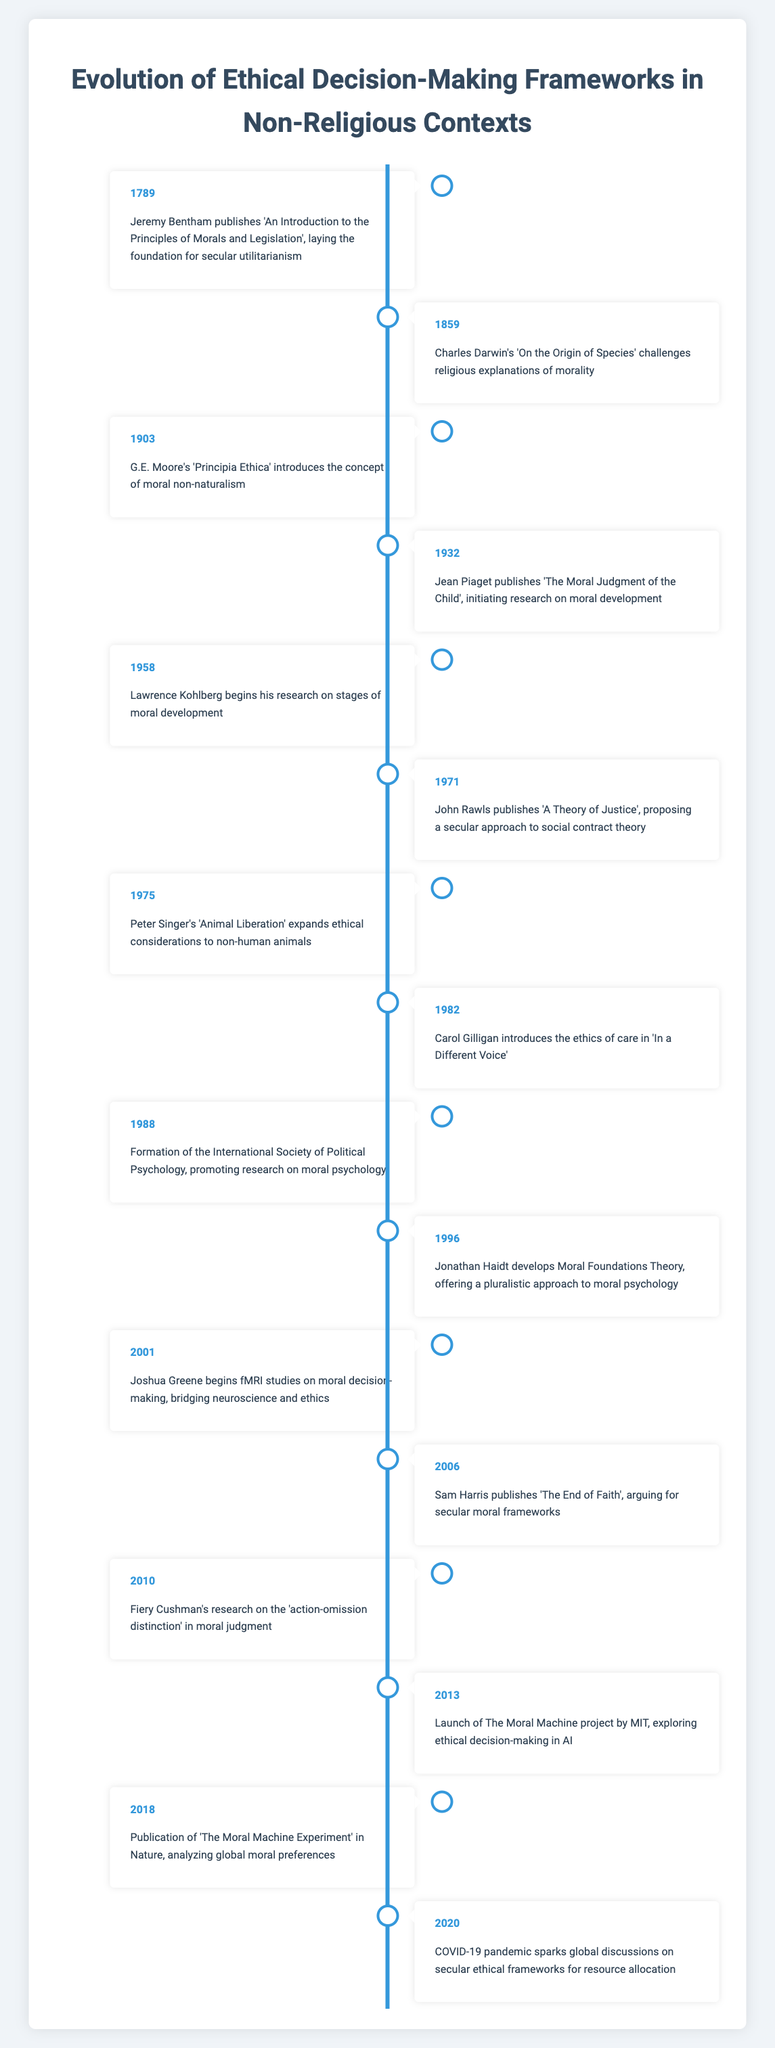What significant event related to ethical decision-making occurred in 1789? In 1789, Jeremy Bentham published 'An Introduction to the Principles of Morals and Legislation', which is significant as it laid the foundation for secular utilitarianism. This is directly noted in the timeline.
Answer: Jeremy Bentham publishes 'An Introduction to the Principles of Morals and Legislation', laying the foundation for secular utilitarianism Which work by John Rawls proposed a secular social contract theory, and in what year was it published? John Rawls published 'A Theory of Justice' in 1971, which proposed a secular approach to social contract theory. This is specifically stated in the timeline.
Answer: 'A Theory of Justice' in 1971 Is it true that the formation of the International Society of Political Psychology took place before the launch of The Moral Machine project? Yes, the timeline indicates that the formation of the International Society of Political Psychology occurred in 1988, while The Moral Machine project was launched in 2013, making the statement true.
Answer: Yes What can be inferred about the evolution of moral psychology from the events listed between 1932 and 1996? Between 1932 and 1996, events include Jean Piaget's work on moral development (1932), Lawrence Kohlberg's research on moral development stages (1958), the formation of the International Society of Political Psychology (1988), and Jonathan Haidt's Moral Foundations Theory (1996). This indicates a growing interest and development in understanding moral psychology through systematic research.
Answer: The evolution indicates increasing systematic research interest in moral psychology How many events mentioned in the timeline specifically address non-human animal ethics? There are two events addressing non-human animal ethics: Peter Singer's 'Animal Liberation' in 1975 and its expansion in ethical considerations, which indicates a recurring focus on animal ethics in the non-religious decision-making framework.
Answer: Two events In what context did the COVID-19 pandemic influence ethical discussions according to the timeline? According to the timeline, the COVID-19 pandemic sparked global discussions on secular ethical frameworks for resource allocation in 2020. This highlights how real-world issues can drive discussions on ethical frameworks.
Answer: Secular ethical frameworks for resource allocation What are the years of publication for G.E. Moore's and Carol Gilligan's significant works, and what do they contribute to ethical decision-making? G.E. Moore's 'Principia Ethica' was published in 1903, contributing to moral non-naturalism, while Carol Gilligan's 'In a Different Voice' was published in 1982, introducing the ethics of care. Both works contributed significantly to understanding diverse moral perspectives in decision-making.
Answer: 1903 for Moore; 1982 for Gilligan 